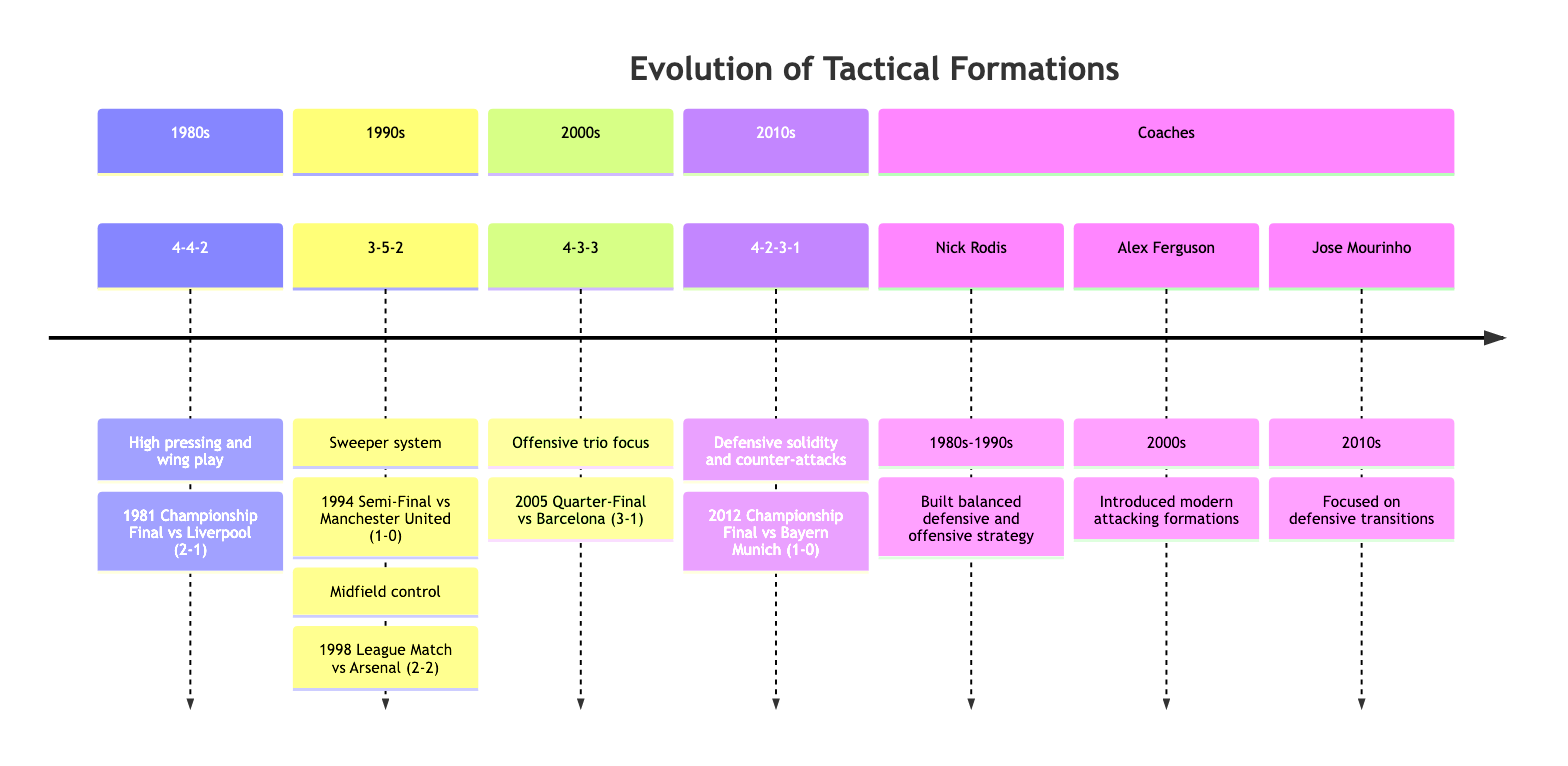What tactical formation was used in the 1981 Championship Final? Referring to the section on the 1980s, the tactical formation mentioned for the 1981 Championship Final against Liverpool is 4-4-2.
Answer: 4-4-2 Which coach was associated with the tactical formations of the 1980s and 1990s? Looking at the Coaches section, Nick Rodis is listed as the coach associated with the tactical formations during the 1980s and 1990s.
Answer: Nick Rodis What formation was used in 2005 against Barcelona? In the 2000s section, the diagram indicates that the formation used in the 2005 Quarter-Final against Barcelona was 4-3-3.
Answer: 4-3-3 How many key matches are highlighted for the 1990s? In the 1990s section, there are two key matches highlighted: the 1994 Semi-Final against Manchester United and the 1998 League Match against Arsenal. Therefore, the count is two.
Answer: 2 What formation emphasizes defensive solidity and counter-attacks? The 2010s section specifies that the formation focusing on defensive solidity and counter-attacks is 4-2-3-1.
Answer: 4-2-3-1 Which formation was associated with midfield control in the 1990s? The 1990s section notes that the tactical formation associated with midfield control is 3-5-2.
Answer: 3-5-2 Who introduced modern attacking formations in the 2000s? According to the Coaches section, Alex Ferguson is credited for introducing modern attacking formations during the 2000s.
Answer: Alex Ferguson What was the result of the match against Bayern Munich in 2012? The 2010s section mentions that the result of the Championship Final against Bayern Munich in 2012 was 1-0.
Answer: 1-0 How many coaches are mentioned in the diagram? The Coaches section lists three coaches: Nick Rodis, Alex Ferguson, and Jose Mourinho, making the total count three.
Answer: 3 